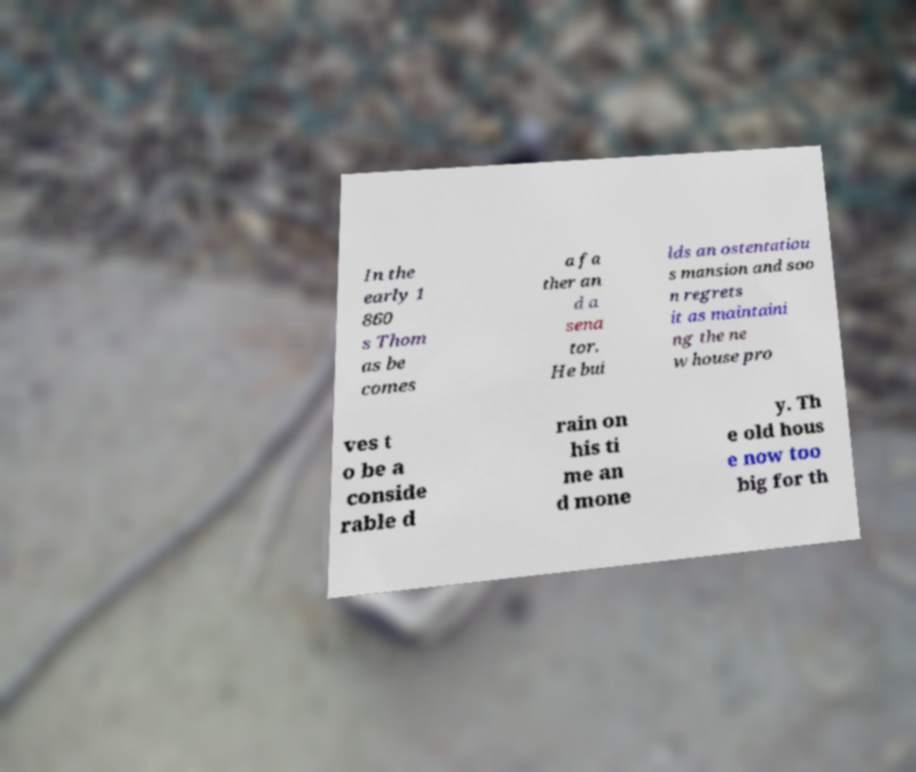Can you accurately transcribe the text from the provided image for me? In the early 1 860 s Thom as be comes a fa ther an d a sena tor. He bui lds an ostentatiou s mansion and soo n regrets it as maintaini ng the ne w house pro ves t o be a conside rable d rain on his ti me an d mone y. Th e old hous e now too big for th 